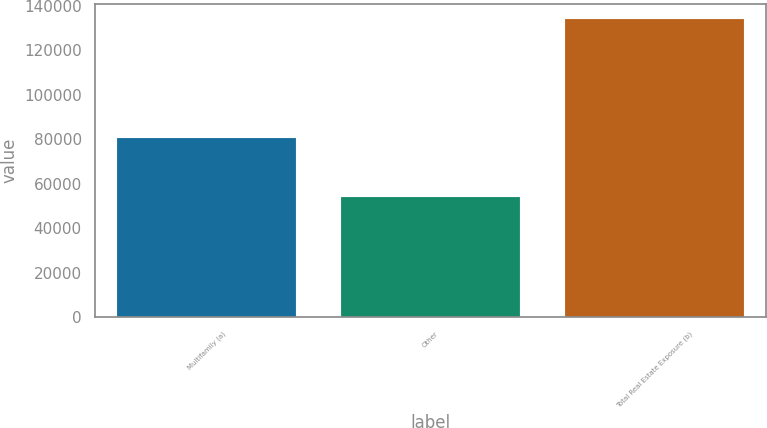Convert chart to OTSL. <chart><loc_0><loc_0><loc_500><loc_500><bar_chart><fcel>Multifamily (a)<fcel>Other<fcel>Total Real Estate Exposure (b)<nl><fcel>80280<fcel>53801<fcel>134081<nl></chart> 